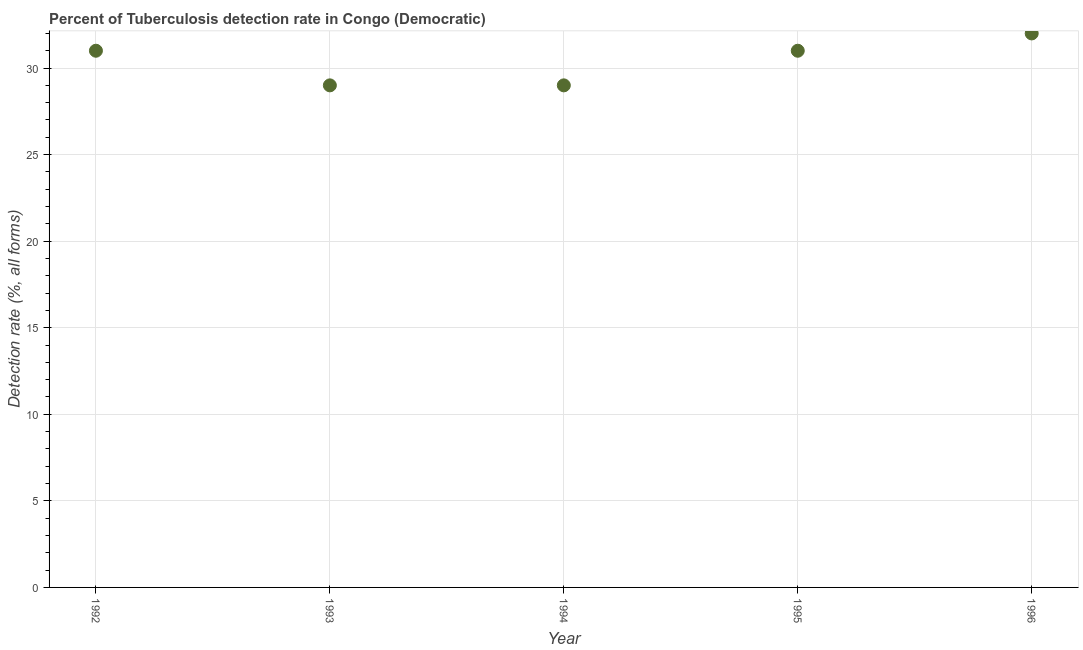What is the detection rate of tuberculosis in 1996?
Keep it short and to the point. 32. Across all years, what is the maximum detection rate of tuberculosis?
Offer a very short reply. 32. Across all years, what is the minimum detection rate of tuberculosis?
Your response must be concise. 29. In which year was the detection rate of tuberculosis minimum?
Offer a terse response. 1993. What is the sum of the detection rate of tuberculosis?
Provide a short and direct response. 152. What is the difference between the detection rate of tuberculosis in 1993 and 1996?
Provide a short and direct response. -3. What is the average detection rate of tuberculosis per year?
Provide a succinct answer. 30.4. What is the median detection rate of tuberculosis?
Your answer should be very brief. 31. In how many years, is the detection rate of tuberculosis greater than 10 %?
Provide a succinct answer. 5. Do a majority of the years between 1993 and 1996 (inclusive) have detection rate of tuberculosis greater than 7 %?
Your response must be concise. Yes. What is the ratio of the detection rate of tuberculosis in 1992 to that in 1996?
Give a very brief answer. 0.97. Is the detection rate of tuberculosis in 1995 less than that in 1996?
Keep it short and to the point. Yes. What is the difference between the highest and the second highest detection rate of tuberculosis?
Your answer should be very brief. 1. Is the sum of the detection rate of tuberculosis in 1994 and 1995 greater than the maximum detection rate of tuberculosis across all years?
Give a very brief answer. Yes. What is the difference between the highest and the lowest detection rate of tuberculosis?
Keep it short and to the point. 3. Does the detection rate of tuberculosis monotonically increase over the years?
Offer a terse response. No. How many dotlines are there?
Your answer should be very brief. 1. How many years are there in the graph?
Offer a terse response. 5. Are the values on the major ticks of Y-axis written in scientific E-notation?
Your answer should be very brief. No. Does the graph contain grids?
Keep it short and to the point. Yes. What is the title of the graph?
Your answer should be very brief. Percent of Tuberculosis detection rate in Congo (Democratic). What is the label or title of the Y-axis?
Provide a short and direct response. Detection rate (%, all forms). What is the Detection rate (%, all forms) in 1992?
Your response must be concise. 31. What is the Detection rate (%, all forms) in 1994?
Keep it short and to the point. 29. What is the Detection rate (%, all forms) in 1996?
Ensure brevity in your answer.  32. What is the difference between the Detection rate (%, all forms) in 1992 and 1993?
Provide a short and direct response. 2. What is the difference between the Detection rate (%, all forms) in 1992 and 1995?
Provide a short and direct response. 0. What is the difference between the Detection rate (%, all forms) in 1993 and 1994?
Offer a terse response. 0. What is the difference between the Detection rate (%, all forms) in 1993 and 1995?
Ensure brevity in your answer.  -2. What is the difference between the Detection rate (%, all forms) in 1994 and 1995?
Offer a very short reply. -2. What is the difference between the Detection rate (%, all forms) in 1994 and 1996?
Your answer should be compact. -3. What is the ratio of the Detection rate (%, all forms) in 1992 to that in 1993?
Keep it short and to the point. 1.07. What is the ratio of the Detection rate (%, all forms) in 1992 to that in 1994?
Keep it short and to the point. 1.07. What is the ratio of the Detection rate (%, all forms) in 1992 to that in 1995?
Make the answer very short. 1. What is the ratio of the Detection rate (%, all forms) in 1992 to that in 1996?
Give a very brief answer. 0.97. What is the ratio of the Detection rate (%, all forms) in 1993 to that in 1995?
Keep it short and to the point. 0.94. What is the ratio of the Detection rate (%, all forms) in 1993 to that in 1996?
Keep it short and to the point. 0.91. What is the ratio of the Detection rate (%, all forms) in 1994 to that in 1995?
Ensure brevity in your answer.  0.94. What is the ratio of the Detection rate (%, all forms) in 1994 to that in 1996?
Ensure brevity in your answer.  0.91. 